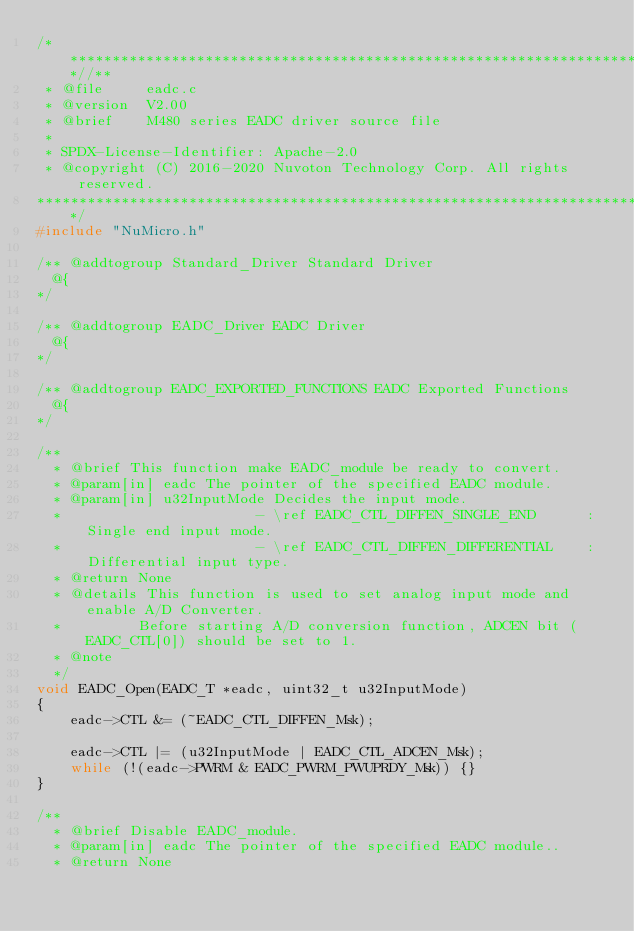Convert code to text. <code><loc_0><loc_0><loc_500><loc_500><_C_>/**************************************************************************//**
 * @file     eadc.c
 * @version  V2.00
 * @brief    M480 series EADC driver source file
 *
 * SPDX-License-Identifier: Apache-2.0
 * @copyright (C) 2016-2020 Nuvoton Technology Corp. All rights reserved.
*****************************************************************************/
#include "NuMicro.h"

/** @addtogroup Standard_Driver Standard Driver
  @{
*/

/** @addtogroup EADC_Driver EADC Driver
  @{
*/

/** @addtogroup EADC_EXPORTED_FUNCTIONS EADC Exported Functions
  @{
*/

/**
  * @brief This function make EADC_module be ready to convert.
  * @param[in] eadc The pointer of the specified EADC module.
  * @param[in] u32InputMode Decides the input mode.
  *                       - \ref EADC_CTL_DIFFEN_SINGLE_END      :Single end input mode.
  *                       - \ref EADC_CTL_DIFFEN_DIFFERENTIAL    :Differential input type.
  * @return None
  * @details This function is used to set analog input mode and enable A/D Converter.
  *         Before starting A/D conversion function, ADCEN bit (EADC_CTL[0]) should be set to 1.
  * @note
  */
void EADC_Open(EADC_T *eadc, uint32_t u32InputMode)
{
    eadc->CTL &= (~EADC_CTL_DIFFEN_Msk);

    eadc->CTL |= (u32InputMode | EADC_CTL_ADCEN_Msk);
    while (!(eadc->PWRM & EADC_PWRM_PWUPRDY_Msk)) {}
}

/**
  * @brief Disable EADC_module.
  * @param[in] eadc The pointer of the specified EADC module..
  * @return None</code> 